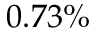<formula> <loc_0><loc_0><loc_500><loc_500>0 . 7 3 \%</formula> 